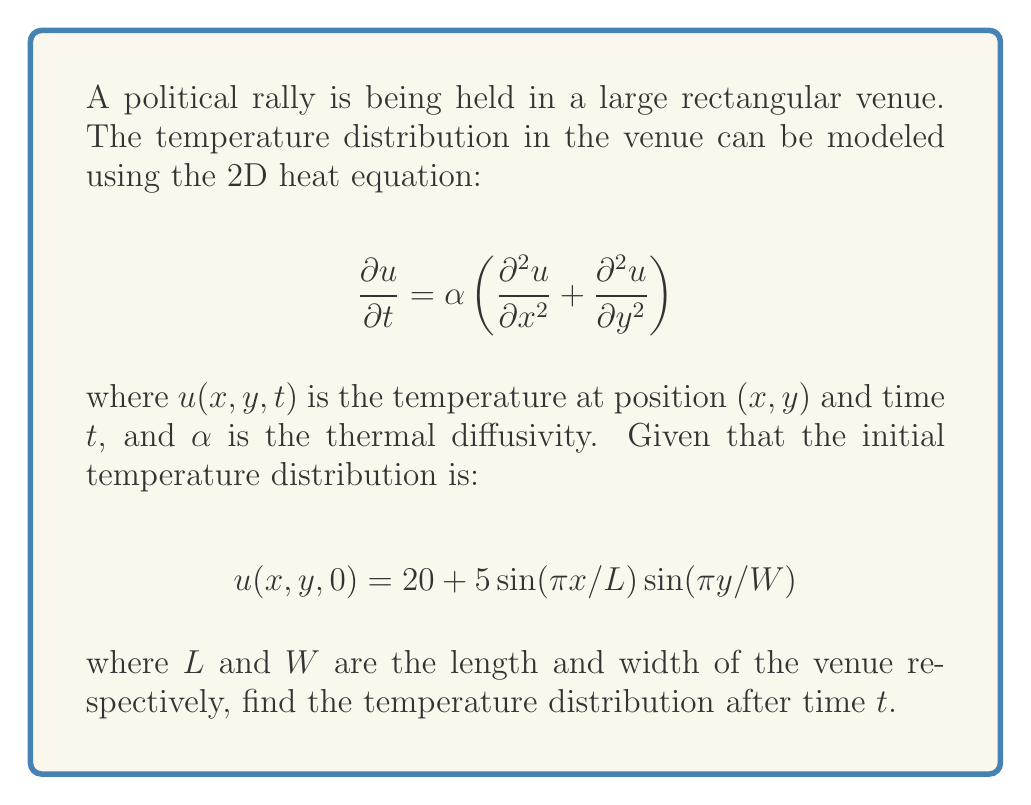Help me with this question. To solve this problem, we'll use the method of separation of variables:

1) Assume a solution of the form: $u(x,y,t) = X(x)Y(y)T(t)$

2) Substituting this into the heat equation:

   $$XY\frac{dT}{dt} = \alpha\left(T\frac{d^2X}{dx^2}Y + TX\frac{d^2Y}{dy^2}\right)$$

3) Dividing by $XYT$:

   $$\frac{1}{T}\frac{dT}{dt} = \alpha\left(\frac{1}{X}\frac{d^2X}{dx^2} + \frac{1}{Y}\frac{d^2Y}{dy^2}\right) = -k^2$$

   where $k^2$ is a constant.

4) This gives us three ODEs:
   
   $$\frac{d^2X}{dx^2} + \lambda_1^2X = 0$$
   $$\frac{d^2Y}{dy^2} + \lambda_2^2Y = 0$$
   $$\frac{dT}{dt} + \alpha k^2T = 0$$

   where $k^2 = \lambda_1^2 + \lambda_2^2$

5) The solutions to these equations are:

   $$X(x) = A\sin(\lambda_1x) + B\cos(\lambda_1x)$$
   $$Y(y) = C\sin(\lambda_2y) + D\cos(\lambda_2y)$$
   $$T(t) = Ee^{-\alpha k^2t}$$

6) Given the initial condition, we can see that $\lambda_1 = \pi/L$ and $\lambda_2 = \pi/W$

7) Therefore, the solution is of the form:

   $$u(x,y,t) = 20 + 5\sin(\pi x/L)\sin(\pi y/W)e^{-\alpha(\pi^2/L^2 + \pi^2/W^2)t}$$

This satisfies the initial condition and the heat equation.
Answer: $u(x,y,t) = 20 + 5\sin(\pi x/L)\sin(\pi y/W)e^{-\alpha(\pi^2/L^2 + \pi^2/W^2)t}$ 